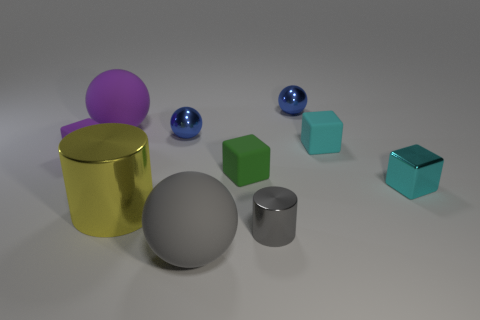There is a purple matte object that is the same shape as the tiny cyan matte thing; what size is it?
Offer a very short reply. Small. What is the large yellow cylinder made of?
Make the answer very short. Metal. What is the tiny thing in front of the small cyan shiny block in front of the blue metal sphere on the left side of the tiny green thing made of?
Your response must be concise. Metal. There is a metallic cylinder that is in front of the yellow metallic thing; is it the same size as the metallic thing that is behind the big purple thing?
Ensure brevity in your answer.  Yes. What number of other things are there of the same material as the gray cylinder
Provide a succinct answer. 4. How many metallic objects are either green blocks or big gray spheres?
Keep it short and to the point. 0. Is the number of tiny cyan rubber cubes less than the number of yellow blocks?
Make the answer very short. No. Does the metallic block have the same size as the ball that is in front of the green thing?
Ensure brevity in your answer.  No. What size is the cyan metal block?
Provide a short and direct response. Small. Is the number of yellow things that are on the right side of the gray metal thing less than the number of large green cylinders?
Your answer should be very brief. No. 